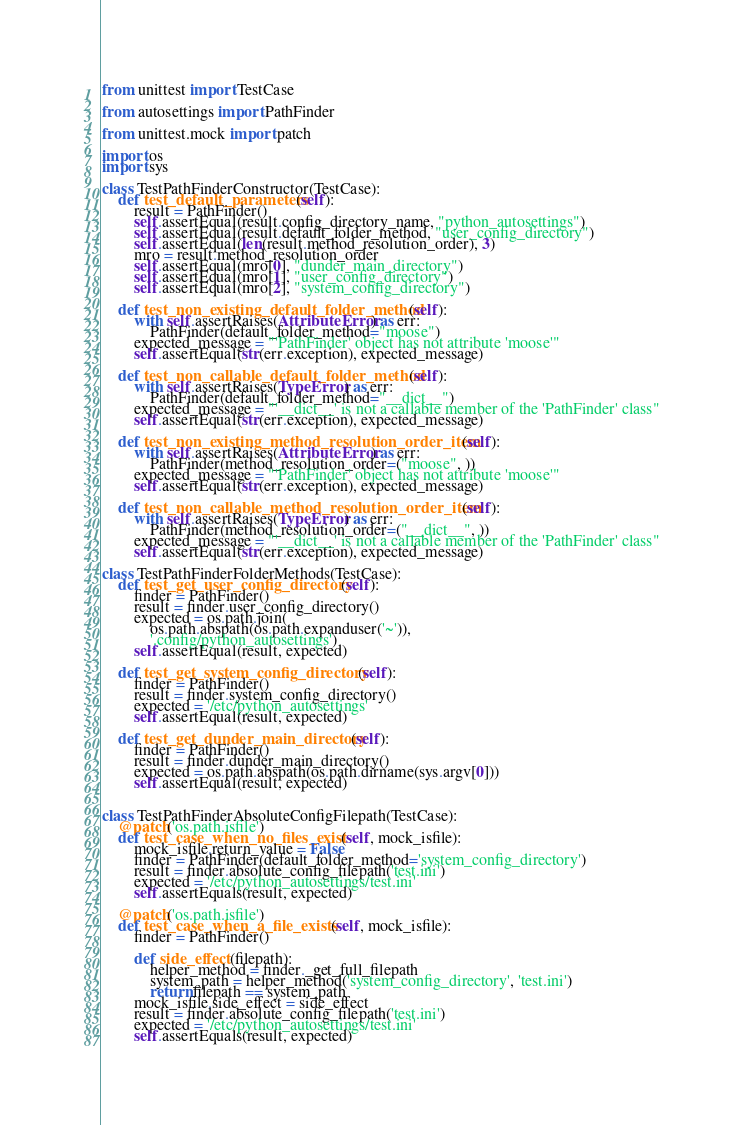Convert code to text. <code><loc_0><loc_0><loc_500><loc_500><_Python_>from unittest import TestCase

from autosettings import PathFinder

from unittest.mock import patch

import os
import sys

class TestPathFinderConstructor(TestCase):
    def test_default_parameters(self):
        result = PathFinder()
        self.assertEqual(result.config_directory_name, "python_autosettings")
        self.assertEqual(result.default_folder_method, "user_config_directory")
        self.assertEqual(len(result.method_resolution_order), 3)
        mro = result.method_resolution_order
        self.assertEqual(mro[0], "dunder_main_directory")
        self.assertEqual(mro[1], "user_config_directory")
        self.assertEqual(mro[2], "system_config_directory")

    def test_non_existing_default_folder_method(self):
        with self.assertRaises(AttributeError) as err:
            PathFinder(default_folder_method="moose")
        expected_message = "'PathFinder' object has not attribute 'moose'"
        self.assertEqual(str(err.exception), expected_message)

    def test_non_callable_default_folder_method(self):
        with self.assertRaises(TypeError) as err:
            PathFinder(default_folder_method="__dict__")
        expected_message = "'__dict__' is not a callable member of the 'PathFinder' class"
        self.assertEqual(str(err.exception), expected_message)

    def test_non_existing_method_resolution_order_item(self):
        with self.assertRaises(AttributeError) as err:
            PathFinder(method_resolution_order=("moose", ))
        expected_message = "'PathFinder' object has not attribute 'moose'"
        self.assertEqual(str(err.exception), expected_message)

    def test_non_callable_method_resolution_order_item(self):
        with self.assertRaises(TypeError) as err:
            PathFinder(method_resolution_order=("__dict__", ))
        expected_message = "'__dict__' is not a callable member of the 'PathFinder' class"
        self.assertEqual(str(err.exception), expected_message)

class TestPathFinderFolderMethods(TestCase):
    def test_get_user_config_directory(self):
        finder = PathFinder()
        result = finder.user_config_directory()
        expected = os.path.join(
            os.path.abspath(os.path.expanduser('~')),
            '.config/python_autosettings')
        self.assertEqual(result, expected)

    def test_get_system_config_directory(self):
        finder = PathFinder()
        result = finder.system_config_directory()
        expected = '/etc/python_autosettings'
        self.assertEqual(result, expected)

    def test_get_dunder_main_directory(self):
        finder = PathFinder()
        result = finder.dunder_main_directory()
        expected = os.path.abspath(os.path.dirname(sys.argv[0]))
        self.assertEqual(result, expected)


class TestPathFinderAbsoluteConfigFilepath(TestCase):
    @patch('os.path.isfile')
    def test_case_when_no_files_exist(self, mock_isfile):
        mock_isfile.return_value = False
        finder = PathFinder(default_folder_method='system_config_directory')
        result = finder.absolute_config_filepath('test.ini')
        expected = '/etc/python_autosettings/test.ini'
        self.assertEquals(result, expected)

    @patch('os.path.isfile')
    def test_case_when_a_file_exists(self, mock_isfile):
        finder = PathFinder()

        def side_effect(filepath):
            helper_method = finder._get_full_filepath
            system_path = helper_method('system_config_directory', 'test.ini')
            return filepath == system_path
        mock_isfile.side_effect = side_effect
        result = finder.absolute_config_filepath('test.ini')
        expected = '/etc/python_autosettings/test.ini'
        self.assertEquals(result, expected)
</code> 